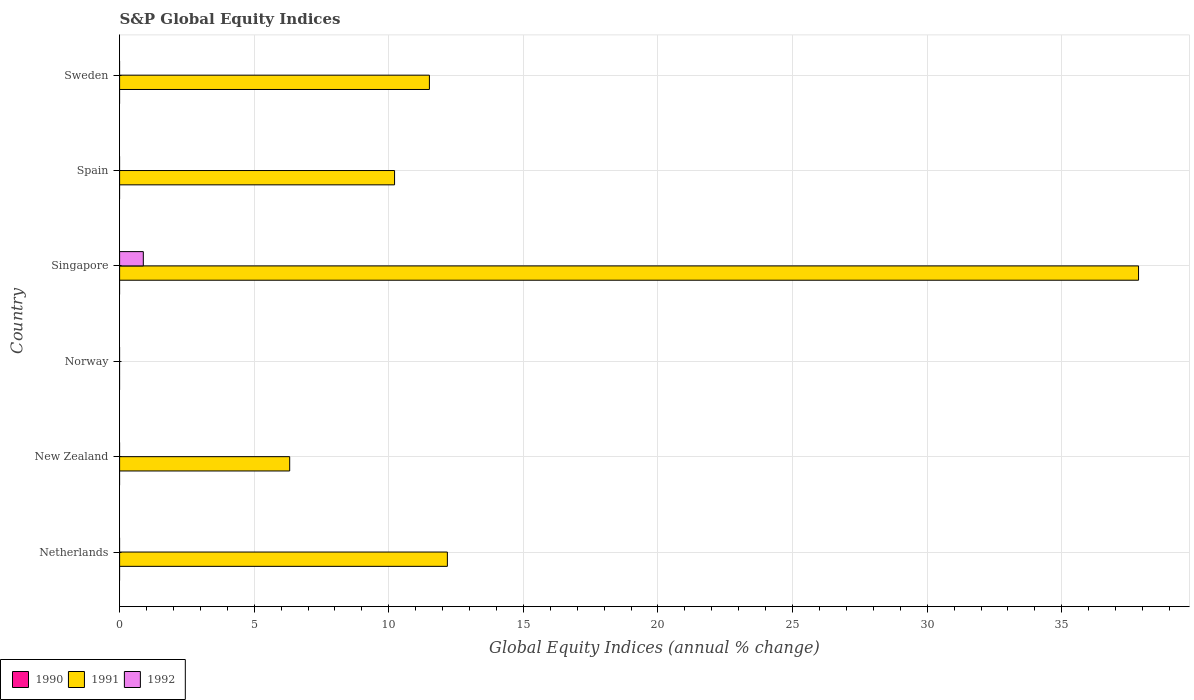How many different coloured bars are there?
Make the answer very short. 2. Are the number of bars per tick equal to the number of legend labels?
Make the answer very short. No. How many bars are there on the 3rd tick from the bottom?
Ensure brevity in your answer.  0. Across all countries, what is the maximum global equity indices in 1991?
Offer a very short reply. 37.85. Across all countries, what is the minimum global equity indices in 1990?
Offer a terse response. 0. In which country was the global equity indices in 1992 maximum?
Ensure brevity in your answer.  Singapore. What is the total global equity indices in 1990 in the graph?
Your answer should be very brief. 0. What is the difference between the global equity indices in 1991 in Netherlands and that in New Zealand?
Your answer should be very brief. 5.86. What is the difference between the global equity indices in 1991 in Spain and the global equity indices in 1992 in Norway?
Make the answer very short. 10.21. What is the average global equity indices in 1990 per country?
Keep it short and to the point. 0. What is the difference between the global equity indices in 1992 and global equity indices in 1991 in Singapore?
Provide a succinct answer. -36.97. What is the ratio of the global equity indices in 1991 in Netherlands to that in Sweden?
Your response must be concise. 1.06. What is the difference between the highest and the second highest global equity indices in 1991?
Offer a very short reply. 25.68. What is the difference between the highest and the lowest global equity indices in 1991?
Provide a succinct answer. 37.85. In how many countries, is the global equity indices in 1991 greater than the average global equity indices in 1991 taken over all countries?
Offer a very short reply. 1. Is it the case that in every country, the sum of the global equity indices in 1990 and global equity indices in 1992 is greater than the global equity indices in 1991?
Give a very brief answer. No. How many bars are there?
Your answer should be compact. 6. Are all the bars in the graph horizontal?
Your response must be concise. Yes. How many countries are there in the graph?
Provide a short and direct response. 6. Are the values on the major ticks of X-axis written in scientific E-notation?
Give a very brief answer. No. Does the graph contain any zero values?
Offer a very short reply. Yes. Does the graph contain grids?
Your response must be concise. Yes. Where does the legend appear in the graph?
Give a very brief answer. Bottom left. How are the legend labels stacked?
Give a very brief answer. Horizontal. What is the title of the graph?
Your answer should be compact. S&P Global Equity Indices. Does "1962" appear as one of the legend labels in the graph?
Ensure brevity in your answer.  No. What is the label or title of the X-axis?
Provide a succinct answer. Global Equity Indices (annual % change). What is the label or title of the Y-axis?
Your answer should be compact. Country. What is the Global Equity Indices (annual % change) in 1990 in Netherlands?
Offer a very short reply. 0. What is the Global Equity Indices (annual % change) in 1991 in Netherlands?
Offer a very short reply. 12.18. What is the Global Equity Indices (annual % change) of 1990 in New Zealand?
Your answer should be very brief. 0. What is the Global Equity Indices (annual % change) of 1991 in New Zealand?
Provide a succinct answer. 6.32. What is the Global Equity Indices (annual % change) of 1992 in Norway?
Your answer should be very brief. 0. What is the Global Equity Indices (annual % change) in 1990 in Singapore?
Your answer should be compact. 0. What is the Global Equity Indices (annual % change) in 1991 in Singapore?
Make the answer very short. 37.85. What is the Global Equity Indices (annual % change) in 1992 in Singapore?
Offer a very short reply. 0.88. What is the Global Equity Indices (annual % change) in 1990 in Spain?
Your response must be concise. 0. What is the Global Equity Indices (annual % change) of 1991 in Spain?
Keep it short and to the point. 10.21. What is the Global Equity Indices (annual % change) in 1992 in Spain?
Provide a succinct answer. 0. What is the Global Equity Indices (annual % change) in 1991 in Sweden?
Keep it short and to the point. 11.51. What is the Global Equity Indices (annual % change) in 1992 in Sweden?
Your answer should be very brief. 0. Across all countries, what is the maximum Global Equity Indices (annual % change) in 1991?
Give a very brief answer. 37.85. Across all countries, what is the maximum Global Equity Indices (annual % change) in 1992?
Your answer should be compact. 0.88. Across all countries, what is the minimum Global Equity Indices (annual % change) of 1991?
Provide a succinct answer. 0. Across all countries, what is the minimum Global Equity Indices (annual % change) of 1992?
Your answer should be compact. 0. What is the total Global Equity Indices (annual % change) in 1991 in the graph?
Keep it short and to the point. 78.07. What is the total Global Equity Indices (annual % change) of 1992 in the graph?
Your response must be concise. 0.88. What is the difference between the Global Equity Indices (annual % change) in 1991 in Netherlands and that in New Zealand?
Give a very brief answer. 5.86. What is the difference between the Global Equity Indices (annual % change) of 1991 in Netherlands and that in Singapore?
Your response must be concise. -25.68. What is the difference between the Global Equity Indices (annual % change) in 1991 in Netherlands and that in Spain?
Your response must be concise. 1.96. What is the difference between the Global Equity Indices (annual % change) of 1991 in Netherlands and that in Sweden?
Your answer should be very brief. 0.67. What is the difference between the Global Equity Indices (annual % change) in 1991 in New Zealand and that in Singapore?
Offer a terse response. -31.53. What is the difference between the Global Equity Indices (annual % change) in 1991 in New Zealand and that in Spain?
Give a very brief answer. -3.9. What is the difference between the Global Equity Indices (annual % change) in 1991 in New Zealand and that in Sweden?
Keep it short and to the point. -5.19. What is the difference between the Global Equity Indices (annual % change) in 1991 in Singapore and that in Spain?
Provide a succinct answer. 27.64. What is the difference between the Global Equity Indices (annual % change) in 1991 in Singapore and that in Sweden?
Offer a terse response. 26.34. What is the difference between the Global Equity Indices (annual % change) in 1991 in Spain and that in Sweden?
Your answer should be very brief. -1.29. What is the difference between the Global Equity Indices (annual % change) of 1991 in Netherlands and the Global Equity Indices (annual % change) of 1992 in Singapore?
Make the answer very short. 11.3. What is the difference between the Global Equity Indices (annual % change) in 1991 in New Zealand and the Global Equity Indices (annual % change) in 1992 in Singapore?
Keep it short and to the point. 5.44. What is the average Global Equity Indices (annual % change) of 1990 per country?
Offer a very short reply. 0. What is the average Global Equity Indices (annual % change) in 1991 per country?
Your answer should be very brief. 13.01. What is the average Global Equity Indices (annual % change) of 1992 per country?
Offer a very short reply. 0.15. What is the difference between the Global Equity Indices (annual % change) of 1991 and Global Equity Indices (annual % change) of 1992 in Singapore?
Offer a terse response. 36.97. What is the ratio of the Global Equity Indices (annual % change) of 1991 in Netherlands to that in New Zealand?
Your answer should be very brief. 1.93. What is the ratio of the Global Equity Indices (annual % change) in 1991 in Netherlands to that in Singapore?
Offer a very short reply. 0.32. What is the ratio of the Global Equity Indices (annual % change) of 1991 in Netherlands to that in Spain?
Offer a very short reply. 1.19. What is the ratio of the Global Equity Indices (annual % change) of 1991 in Netherlands to that in Sweden?
Give a very brief answer. 1.06. What is the ratio of the Global Equity Indices (annual % change) in 1991 in New Zealand to that in Singapore?
Your response must be concise. 0.17. What is the ratio of the Global Equity Indices (annual % change) of 1991 in New Zealand to that in Spain?
Give a very brief answer. 0.62. What is the ratio of the Global Equity Indices (annual % change) of 1991 in New Zealand to that in Sweden?
Keep it short and to the point. 0.55. What is the ratio of the Global Equity Indices (annual % change) in 1991 in Singapore to that in Spain?
Your answer should be very brief. 3.71. What is the ratio of the Global Equity Indices (annual % change) in 1991 in Singapore to that in Sweden?
Offer a terse response. 3.29. What is the ratio of the Global Equity Indices (annual % change) in 1991 in Spain to that in Sweden?
Ensure brevity in your answer.  0.89. What is the difference between the highest and the second highest Global Equity Indices (annual % change) in 1991?
Offer a very short reply. 25.68. What is the difference between the highest and the lowest Global Equity Indices (annual % change) of 1991?
Your response must be concise. 37.85. What is the difference between the highest and the lowest Global Equity Indices (annual % change) in 1992?
Offer a terse response. 0.88. 